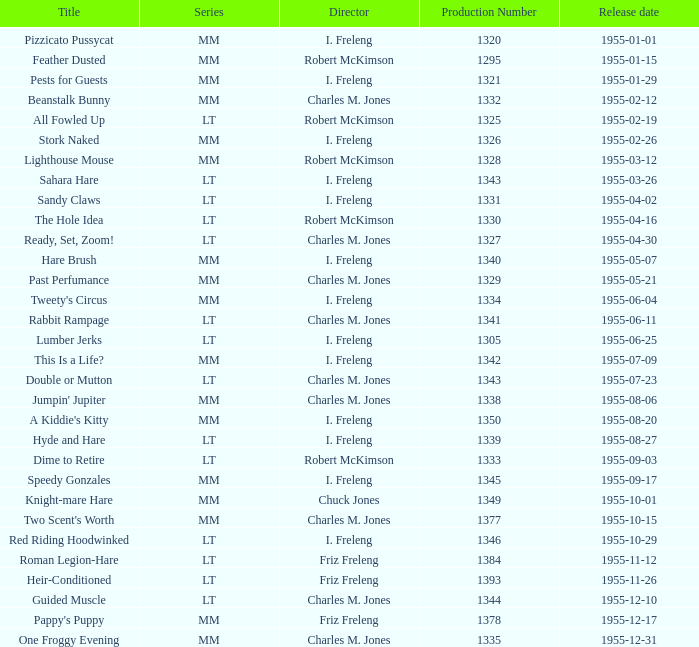What is the release date of production number 1327? 1955-04-30. 